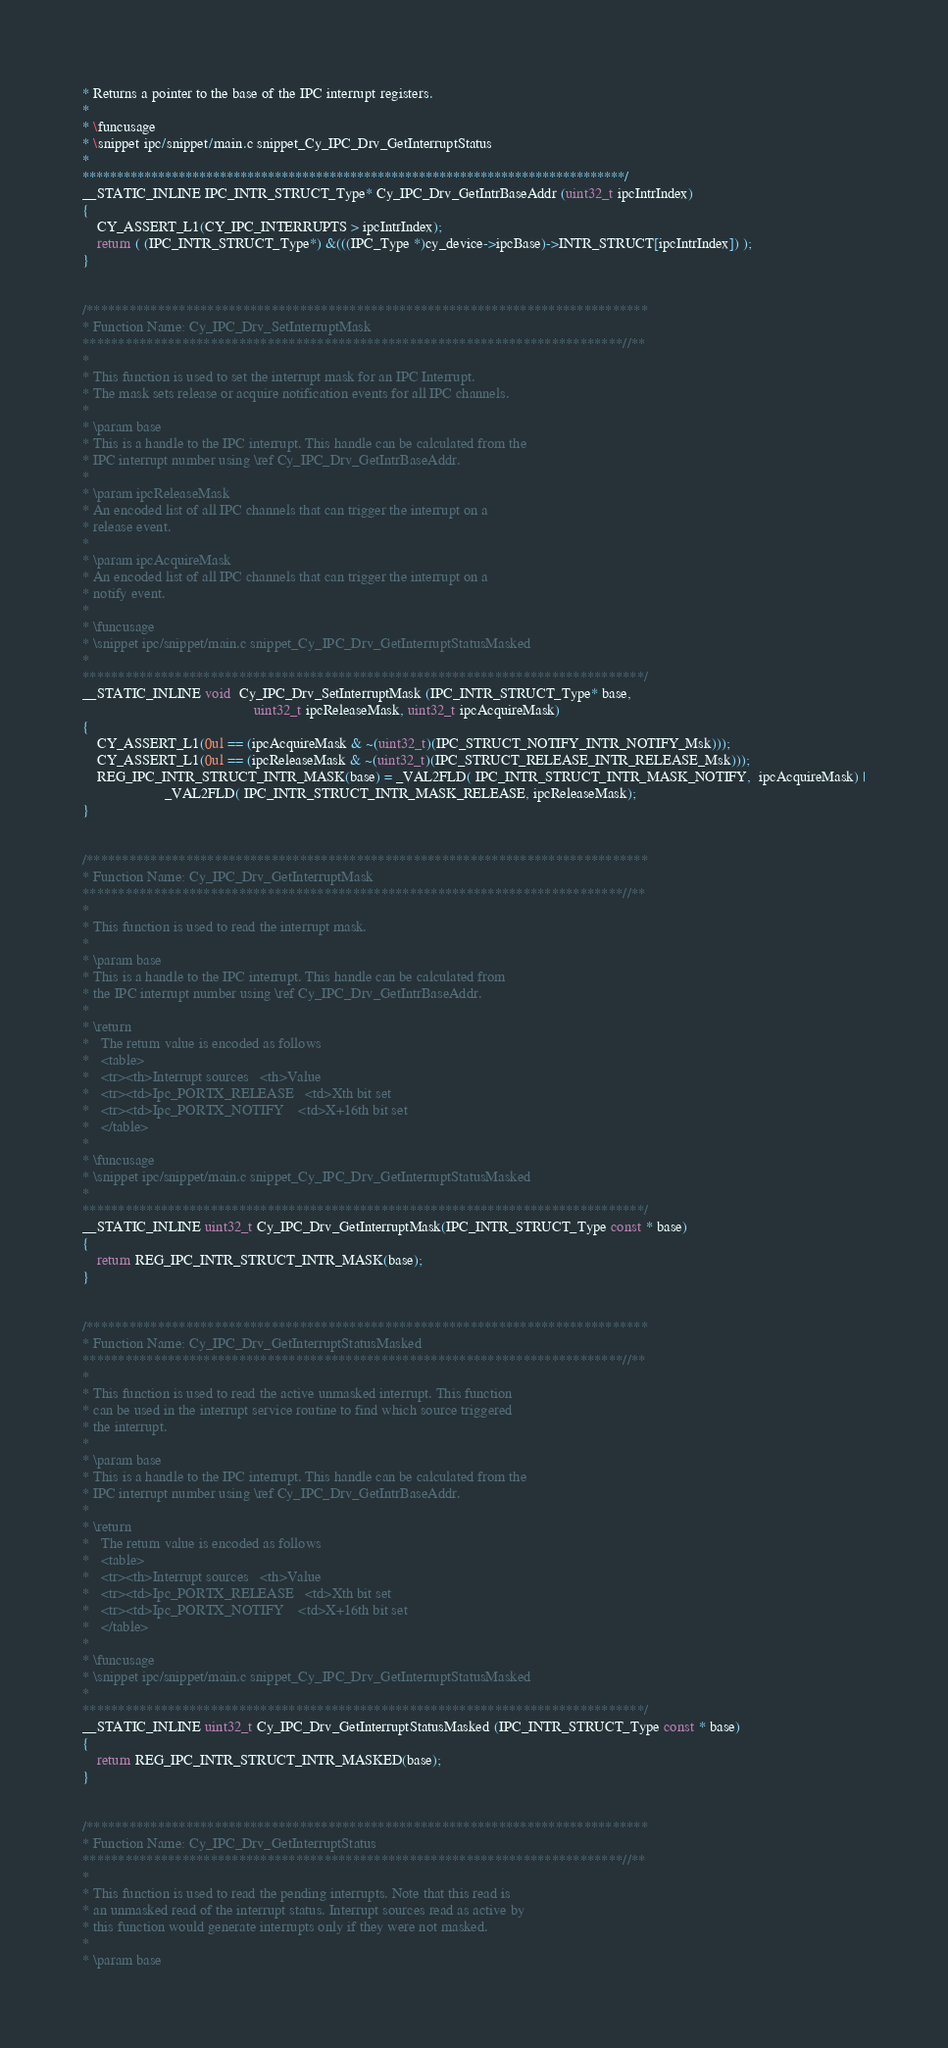<code> <loc_0><loc_0><loc_500><loc_500><_C_>* Returns a pointer to the base of the IPC interrupt registers.
*
* \funcusage
* \snippet ipc/snippet/main.c snippet_Cy_IPC_Drv_GetInterruptStatus
*
*******************************************************************************/
__STATIC_INLINE IPC_INTR_STRUCT_Type* Cy_IPC_Drv_GetIntrBaseAddr (uint32_t ipcIntrIndex)
{
    CY_ASSERT_L1(CY_IPC_INTERRUPTS > ipcIntrIndex);
    return ( (IPC_INTR_STRUCT_Type*) &(((IPC_Type *)cy_device->ipcBase)->INTR_STRUCT[ipcIntrIndex]) );
}


/*******************************************************************************
* Function Name: Cy_IPC_Drv_SetInterruptMask
****************************************************************************//**
*
* This function is used to set the interrupt mask for an IPC Interrupt.
* The mask sets release or acquire notification events for all IPC channels.
*
* \param base
* This is a handle to the IPC interrupt. This handle can be calculated from the
* IPC interrupt number using \ref Cy_IPC_Drv_GetIntrBaseAddr.
*
* \param ipcReleaseMask
* An encoded list of all IPC channels that can trigger the interrupt on a
* release event.
*
* \param ipcAcquireMask
* An encoded list of all IPC channels that can trigger the interrupt on a
* notify event.
*
* \funcusage
* \snippet ipc/snippet/main.c snippet_Cy_IPC_Drv_GetInterruptStatusMasked
*
*******************************************************************************/
__STATIC_INLINE void  Cy_IPC_Drv_SetInterruptMask (IPC_INTR_STRUCT_Type* base,
                                              uint32_t ipcReleaseMask, uint32_t ipcAcquireMask)
{
    CY_ASSERT_L1(0ul == (ipcAcquireMask & ~(uint32_t)(IPC_STRUCT_NOTIFY_INTR_NOTIFY_Msk)));
    CY_ASSERT_L1(0ul == (ipcReleaseMask & ~(uint32_t)(IPC_STRUCT_RELEASE_INTR_RELEASE_Msk)));
    REG_IPC_INTR_STRUCT_INTR_MASK(base) = _VAL2FLD( IPC_INTR_STRUCT_INTR_MASK_NOTIFY,  ipcAcquireMask) |
                      _VAL2FLD( IPC_INTR_STRUCT_INTR_MASK_RELEASE, ipcReleaseMask);
}


/*******************************************************************************
* Function Name: Cy_IPC_Drv_GetInterruptMask
****************************************************************************//**
*
* This function is used to read the interrupt mask.
*
* \param base
* This is a handle to the IPC interrupt. This handle can be calculated from
* the IPC interrupt number using \ref Cy_IPC_Drv_GetIntrBaseAddr.
*
* \return
*   The return value is encoded as follows
*   <table>
*   <tr><th>Interrupt sources   <th>Value
*   <tr><td>Ipc_PORTX_RELEASE   <td>Xth bit set
*   <tr><td>Ipc_PORTX_NOTIFY    <td>X+16th bit set
*   </table>
*
* \funcusage
* \snippet ipc/snippet/main.c snippet_Cy_IPC_Drv_GetInterruptStatusMasked
*
*******************************************************************************/
__STATIC_INLINE uint32_t Cy_IPC_Drv_GetInterruptMask(IPC_INTR_STRUCT_Type const * base)
{
    return REG_IPC_INTR_STRUCT_INTR_MASK(base);
}


/*******************************************************************************
* Function Name: Cy_IPC_Drv_GetInterruptStatusMasked
****************************************************************************//**
*
* This function is used to read the active unmasked interrupt. This function
* can be used in the interrupt service routine to find which source triggered
* the interrupt.
*
* \param base
* This is a handle to the IPC interrupt. This handle can be calculated from the
* IPC interrupt number using \ref Cy_IPC_Drv_GetIntrBaseAddr.
*
* \return
*   The return value is encoded as follows
*   <table>
*   <tr><th>Interrupt sources   <th>Value
*   <tr><td>Ipc_PORTX_RELEASE   <td>Xth bit set
*   <tr><td>Ipc_PORTX_NOTIFY    <td>X+16th bit set
*   </table>
*
* \funcusage
* \snippet ipc/snippet/main.c snippet_Cy_IPC_Drv_GetInterruptStatusMasked
*
*******************************************************************************/
__STATIC_INLINE uint32_t Cy_IPC_Drv_GetInterruptStatusMasked (IPC_INTR_STRUCT_Type const * base)
{
    return REG_IPC_INTR_STRUCT_INTR_MASKED(base);
}


/*******************************************************************************
* Function Name: Cy_IPC_Drv_GetInterruptStatus
****************************************************************************//**
*
* This function is used to read the pending interrupts. Note that this read is
* an unmasked read of the interrupt status. Interrupt sources read as active by
* this function would generate interrupts only if they were not masked.
*
* \param base</code> 